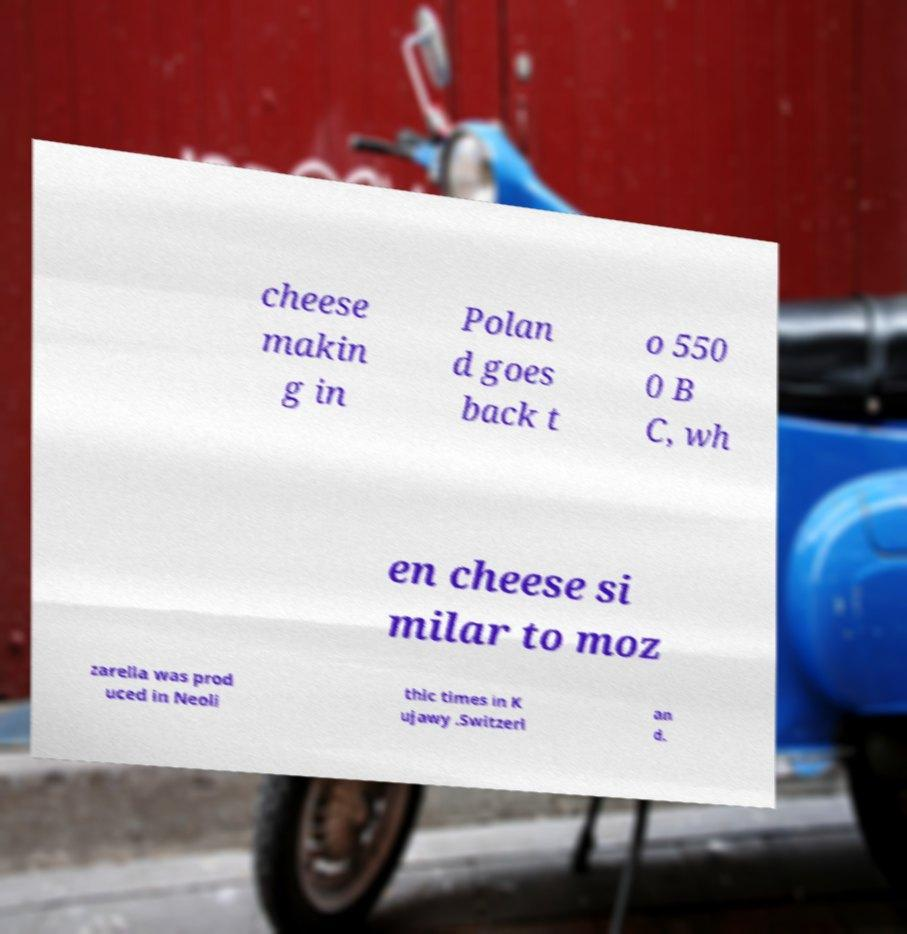I need the written content from this picture converted into text. Can you do that? cheese makin g in Polan d goes back t o 550 0 B C, wh en cheese si milar to moz zarella was prod uced in Neoli thic times in K ujawy .Switzerl an d. 